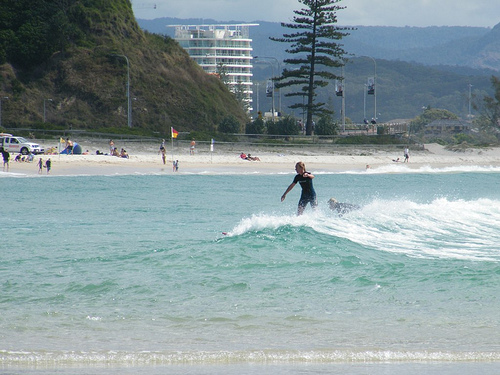Imagine a magical event happening in this scene. Describe it in detail. As the afternoon sun begins to set, the beach is suddenly illuminated by a cascade of shimmering lights. The waves start to glow with an ethereal blue hue as bioluminescent plankton light up the water, creating a mesmerizing spectacle. In the distance, a gentle hum can be heard, growing louder until, out of the ocean, rises a magnificent, glowing sea creature - a combination of a whale and a dragon, with iridescent scales and luminescent fins. People on the beach stand in awe, their faces bathed in the creature’s soft, otherworldly light. The creature, known as the Luminaris, gently glides through the waves, creating a trail of sparkling water. As it reaches the shore, the Luminaris lets out a melodious song that fills the air, soothing and enchanting all who hear it. The flag on the beach begins to emit a magical glow, marking the spot as a gateway between the realms. Children laugh and run towards the water, their footsteps leaving incandescent prints in the sand. The trees on the hillside sway gently, their leaves seemingly whispering secrets of old. The magical event lasts for hours, with the Luminaris interacting with the humans, sharing wisdom and ancient stories. As the event draws to a close, the creature dives back into the ocean, leaving behind a sense of wonder and a promise that the magic will return whenever the hearts of the people need it most. 